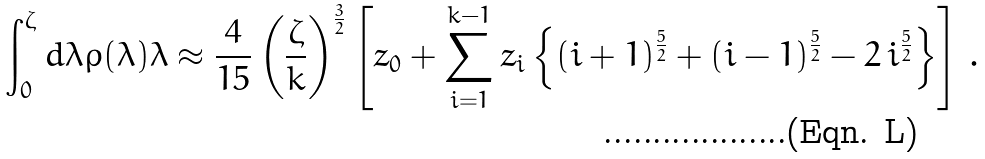<formula> <loc_0><loc_0><loc_500><loc_500>\int _ { 0 } ^ { \zeta } d \lambda \rho ( \lambda ) \lambda \approx \frac { 4 } { 1 5 } \left ( \frac { \zeta } { k } \right ) ^ { \frac { 3 } { 2 } } \left [ z _ { 0 } + \sum _ { i = 1 } ^ { k - 1 } z _ { i } \left \{ ( i + 1 ) ^ { \frac { 5 } { 2 } } + ( i - 1 ) ^ { \frac { 5 } { 2 } } - 2 \, i ^ { \frac { 5 } { 2 } } \right \} \right ] \, .</formula> 